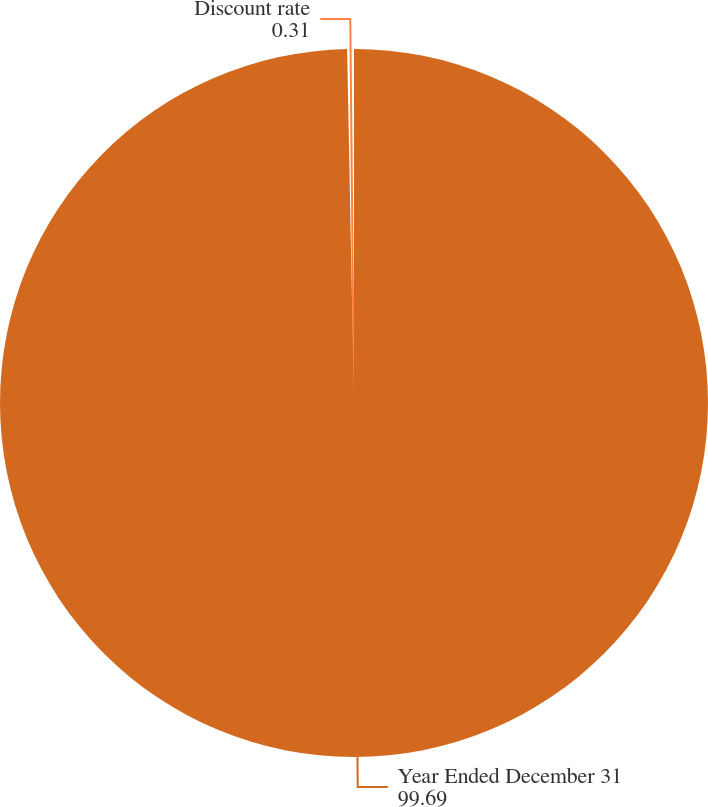Convert chart. <chart><loc_0><loc_0><loc_500><loc_500><pie_chart><fcel>Year Ended December 31<fcel>Discount rate<nl><fcel>99.69%<fcel>0.31%<nl></chart> 